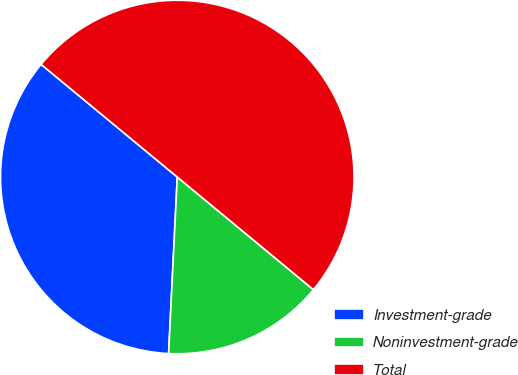Convert chart. <chart><loc_0><loc_0><loc_500><loc_500><pie_chart><fcel>Investment-grade<fcel>Noninvestment-grade<fcel>Total<nl><fcel>35.22%<fcel>14.78%<fcel>50.0%<nl></chart> 